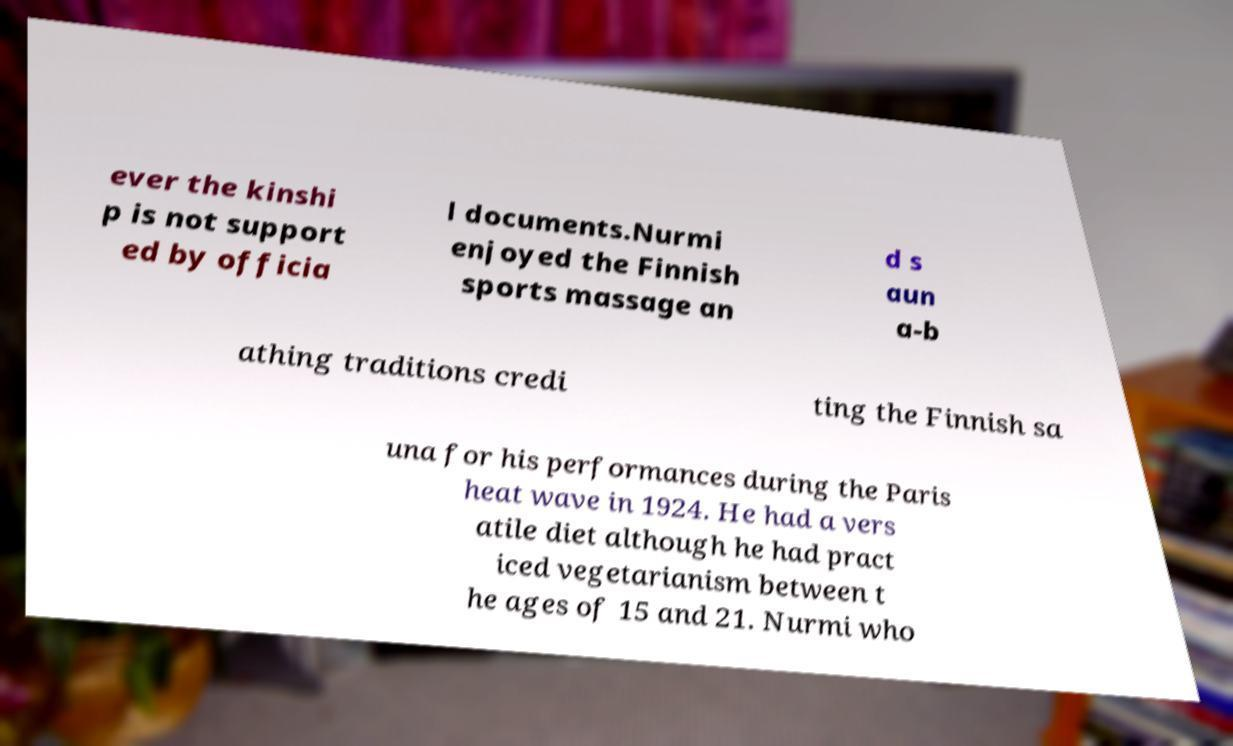Could you extract and type out the text from this image? ever the kinshi p is not support ed by officia l documents.Nurmi enjoyed the Finnish sports massage an d s aun a-b athing traditions credi ting the Finnish sa una for his performances during the Paris heat wave in 1924. He had a vers atile diet although he had pract iced vegetarianism between t he ages of 15 and 21. Nurmi who 